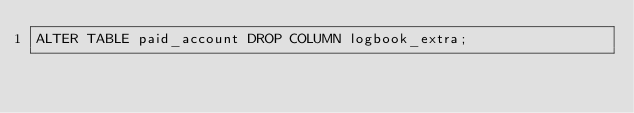<code> <loc_0><loc_0><loc_500><loc_500><_SQL_>ALTER TABLE paid_account DROP COLUMN logbook_extra;</code> 